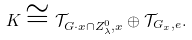Convert formula to latex. <formula><loc_0><loc_0><loc_500><loc_500>K \cong \mathcal { T } _ { G \cdot x \cap Z _ { \lambda } ^ { 0 } , x } \oplus \mathcal { T } _ { G _ { x } , e } .</formula> 